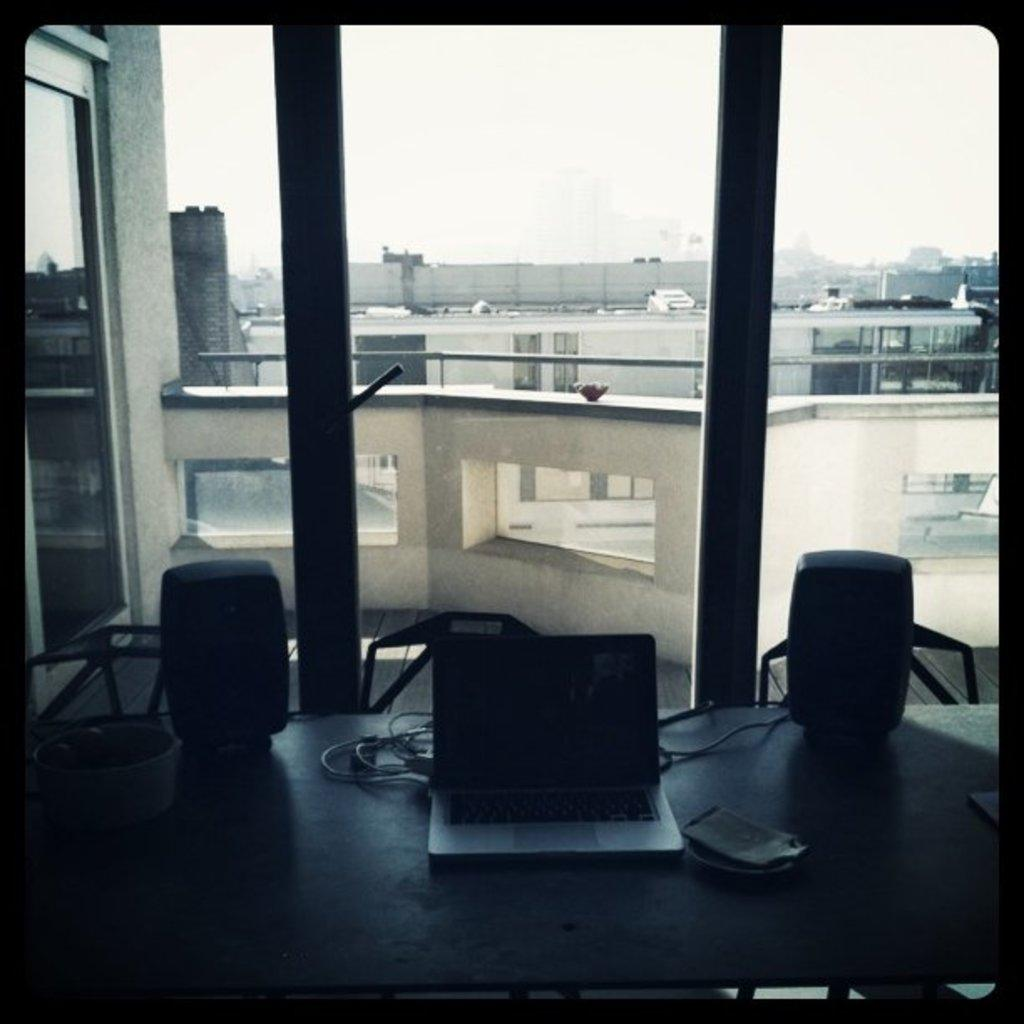What is: What type of structure is visible in the image? There is a glass window in the image. What furniture is present in the image? There is a table and chairs in the image. What electronic device is on the table? There is a laptop on the table. What other object is on the table? There is a cable on the table. What else can be seen on the table? There are other things on the table. What is visible through the glass window? Buildings and the sky are visible through the glass window. What type of nail is being hammered into the table in the image? There is no nail or hammering activity present in the image. Can you see a railway through the glass window in the image? There is no railway visible through the glass window in the image. 